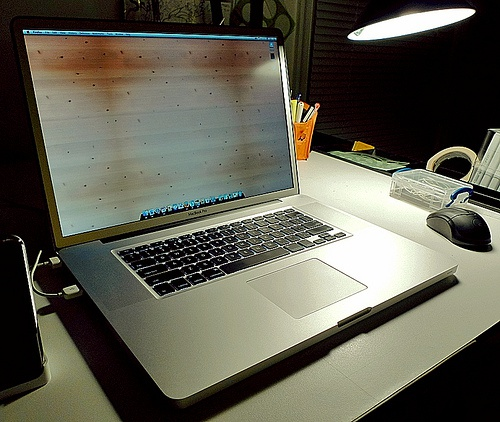Describe the objects in this image and their specific colors. I can see laptop in black, gray, and darkgray tones, cell phone in black, white, gray, and olive tones, and mouse in black, gray, and darkgreen tones in this image. 